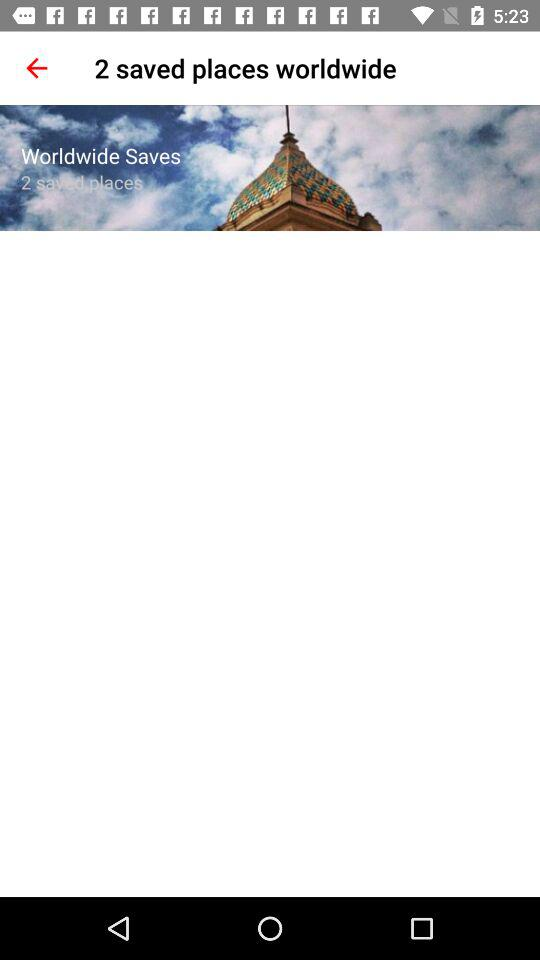How many saved places are there in total?
Answer the question using a single word or phrase. 2 